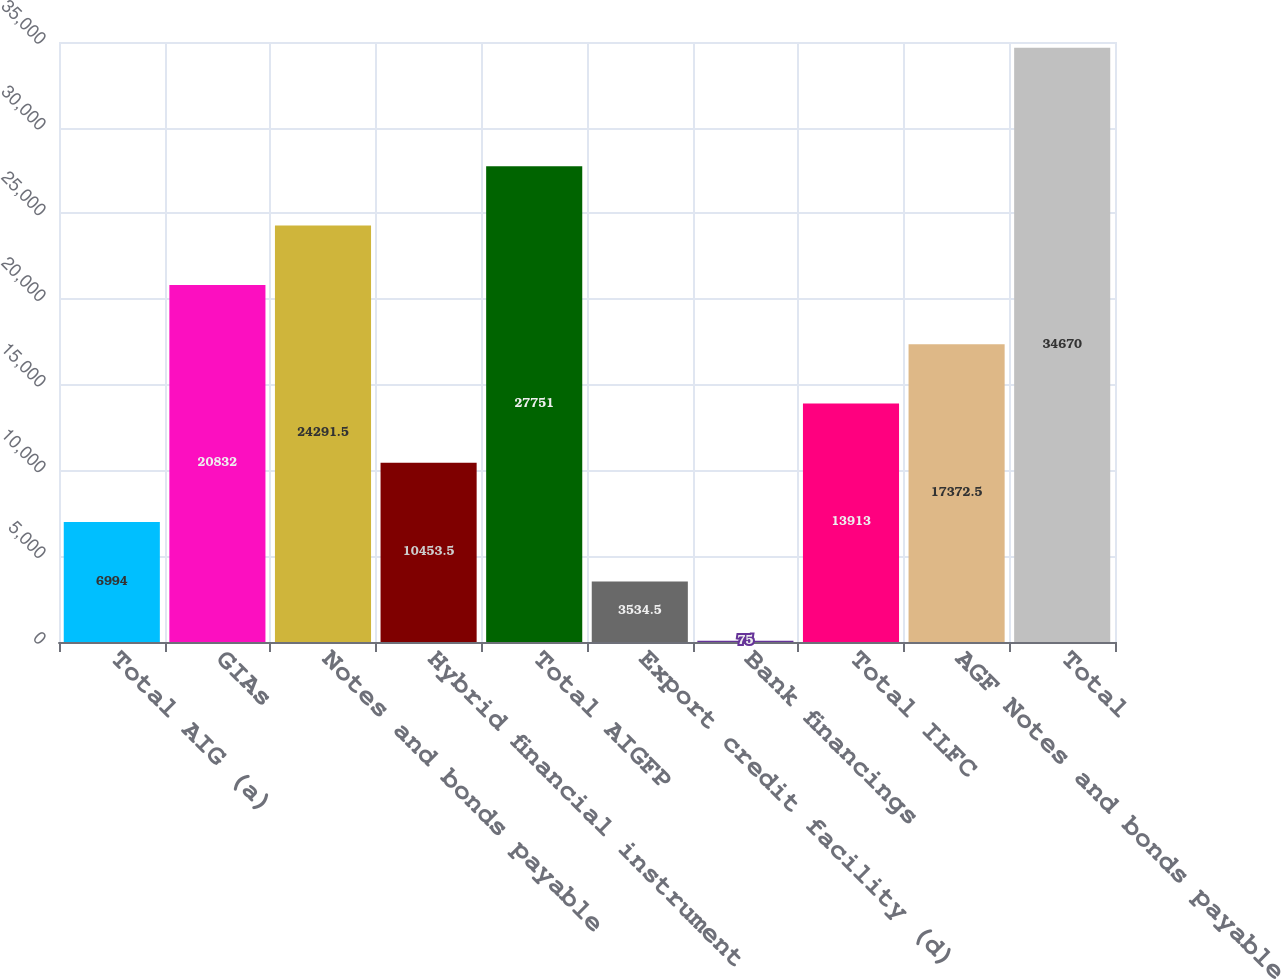<chart> <loc_0><loc_0><loc_500><loc_500><bar_chart><fcel>Total AIG (a)<fcel>GIAs<fcel>Notes and bonds payable<fcel>Hybrid financial instrument<fcel>Total AIGFP<fcel>Export credit facility (d)<fcel>Bank financings<fcel>Total ILFC<fcel>AGF Notes and bonds payable<fcel>Total<nl><fcel>6994<fcel>20832<fcel>24291.5<fcel>10453.5<fcel>27751<fcel>3534.5<fcel>75<fcel>13913<fcel>17372.5<fcel>34670<nl></chart> 